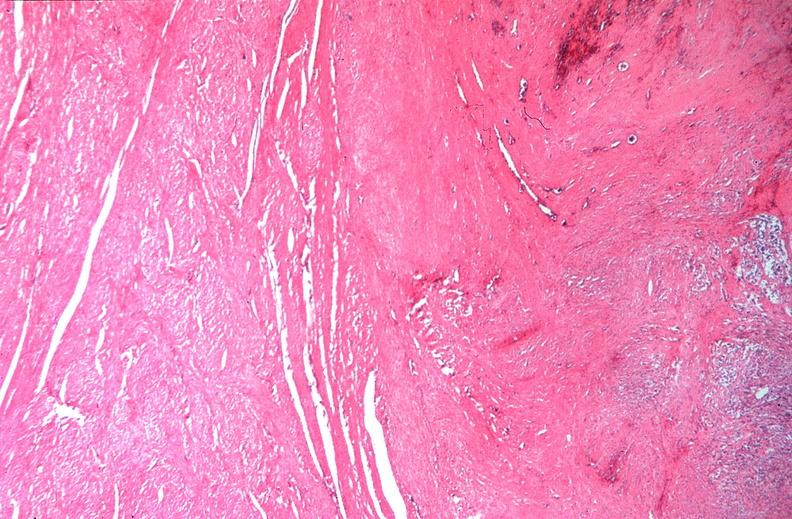s female reproductive present?
Answer the question using a single word or phrase. Yes 